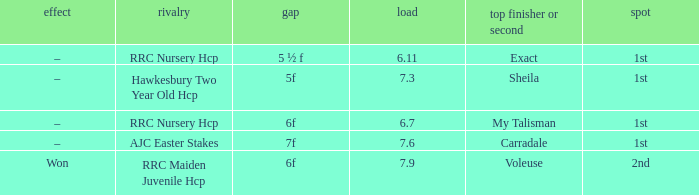What was the race when the winner of 2nd was Voleuse? RRC Maiden Juvenile Hcp. 